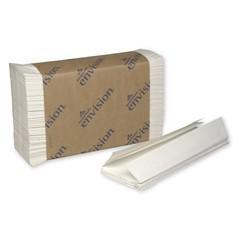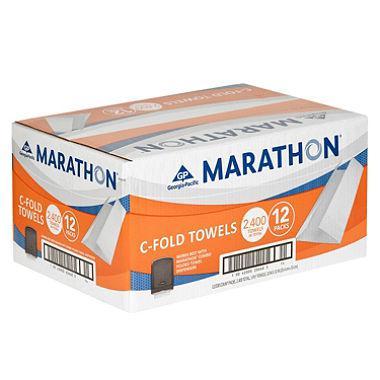The first image is the image on the left, the second image is the image on the right. Evaluate the accuracy of this statement regarding the images: "One image shows a brown paper-wrapped bundle of folded paper towels with a few unwrapped towels in front of it, but no image includes a tall stack of unwrapped folded paper towels.". Is it true? Answer yes or no. Yes. The first image is the image on the left, the second image is the image on the right. For the images shown, is this caption "There is a least one stack of towels wrapped in brown paper" true? Answer yes or no. Yes. 